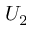Convert formula to latex. <formula><loc_0><loc_0><loc_500><loc_500>U _ { 2 }</formula> 